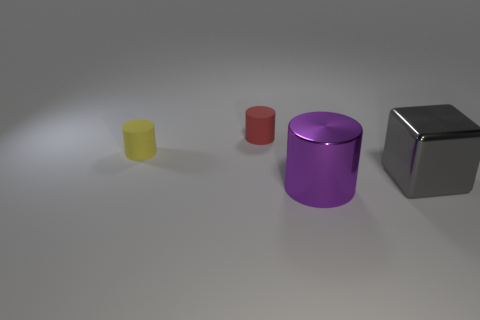How does the lighting in this image affect the appearance of the objects? The lighting in this image creates soft shadows and subtle reflections, indicating a diffused light source. This enhances the three-dimensional form of the objects and contributes to the perception of their material qualities. 